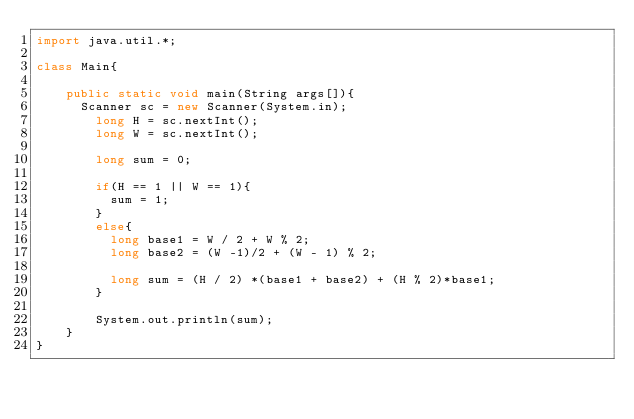Convert code to text. <code><loc_0><loc_0><loc_500><loc_500><_Java_>import java.util.*;

class Main{

    public static void main(String args[]){
    	Scanner sc = new Scanner(System.in);
      	long H = sc.nextInt();
        long W = sc.nextInt();

        long sum = 0;
      	
        if(H == 1 || W == 1){
        	sum = 1;	
        }
      	else{
	      	long base1 = W / 2 + W % 2;
    	  	long base2 = (W -1)/2 + (W - 1) % 2;
      	
      		long sum = (H / 2) *(base1 + base2) + (H % 2)*base1;	
        }
      
        System.out.println(sum);
    }
}</code> 